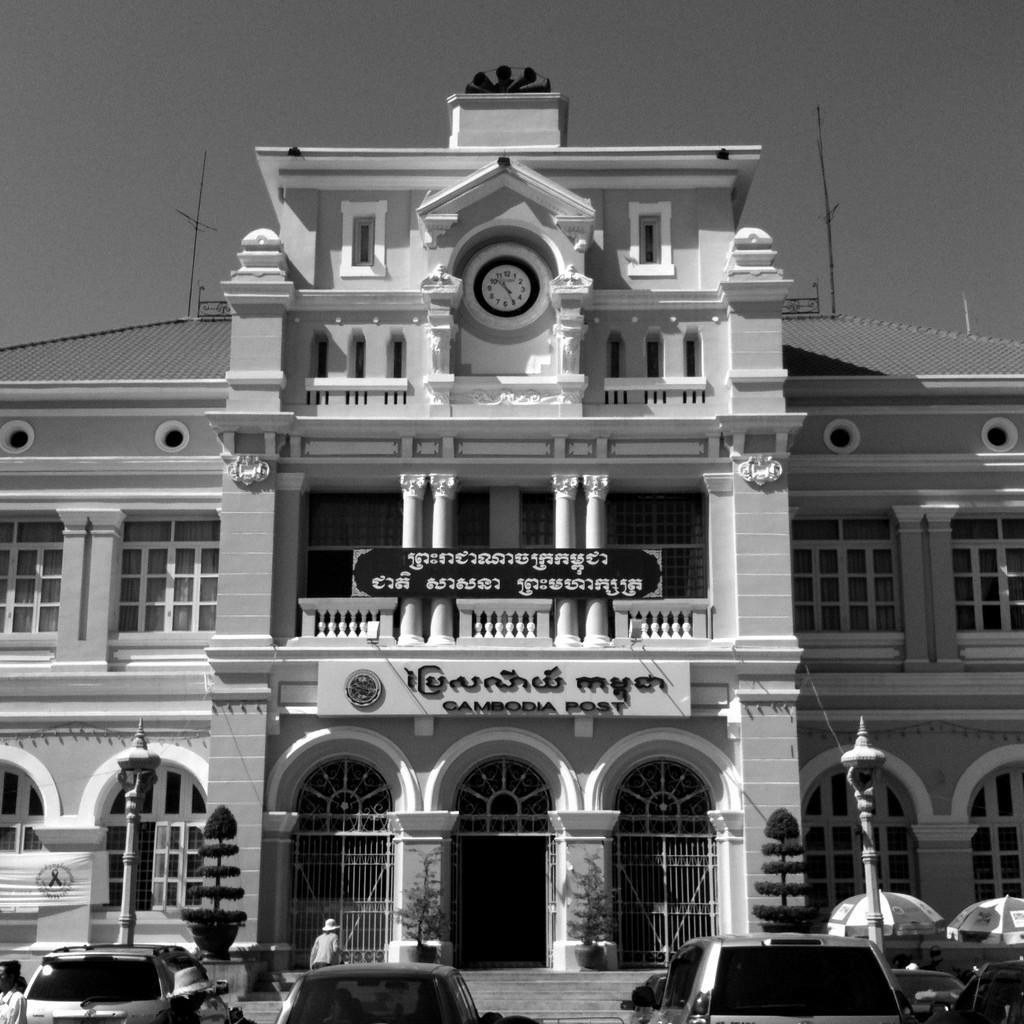Could you give a brief overview of what you see in this image? This is a black and white image. At the bottom there are few cars and poles. In the middle of the image there is a building. At the top of the image I can see the sky. 